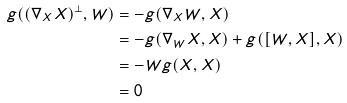Convert formula to latex. <formula><loc_0><loc_0><loc_500><loc_500>g ( ( \nabla _ { X } X ) ^ { \bot } , W ) & = - g ( \nabla _ { X } W , X ) \\ & = - g ( \nabla _ { W } X , X ) + g ( [ W , X ] , X ) \\ & = - W g ( X , X ) \\ & = 0</formula> 